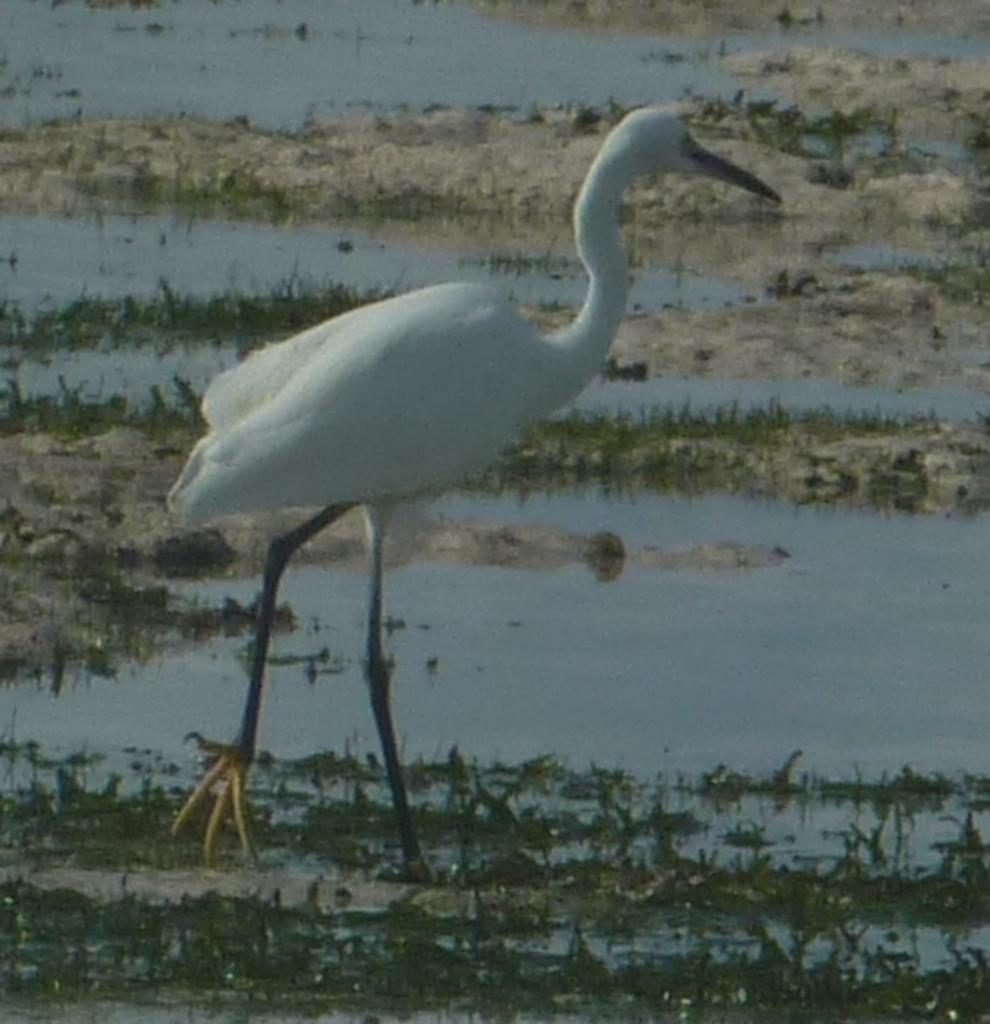What type of animal can be seen in the image? There is a bird in the image. What type of terrain is visible in the image? There is grass, sand, and water visible in the image. What type of bells can be heard ringing in the image? There are no bells present in the image, and therefore no sound can be heard. 